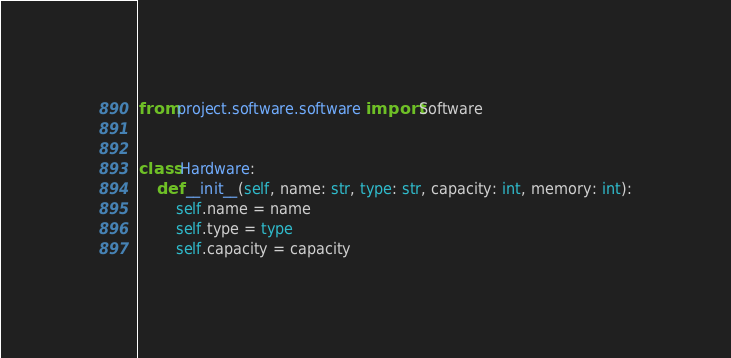Convert code to text. <code><loc_0><loc_0><loc_500><loc_500><_Python_>from project.software.software import Software


class Hardware:
    def __init__(self, name: str, type: str, capacity: int, memory: int):
        self.name = name
        self.type = type
        self.capacity = capacity</code> 